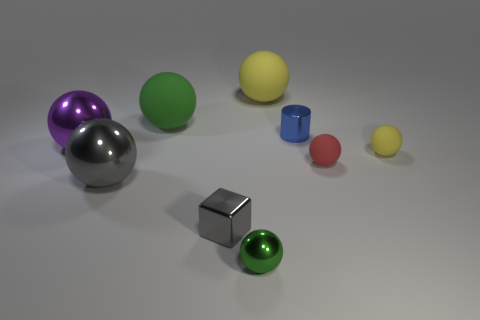Are there the same number of red matte spheres behind the blue cylinder and big red spheres?
Ensure brevity in your answer.  Yes. Are there any objects of the same color as the small shiny block?
Give a very brief answer. Yes. Does the gray shiny block have the same size as the green rubber thing?
Your answer should be compact. No. How big is the matte sphere to the left of the large matte sphere that is behind the green rubber object?
Your response must be concise. Large. There is a metal object that is behind the small yellow rubber sphere and on the right side of the purple shiny object; what is its size?
Offer a terse response. Small. How many green spheres have the same size as the gray metal ball?
Your response must be concise. 1. How many metal things are either purple cylinders or gray balls?
Offer a terse response. 1. What is the size of the metal object that is the same color as the tiny metallic cube?
Give a very brief answer. Large. What is the material of the green sphere that is in front of the large shiny ball that is in front of the big purple metallic ball?
Ensure brevity in your answer.  Metal. What number of objects are either cyan things or tiny balls to the left of the small yellow object?
Offer a very short reply. 2. 